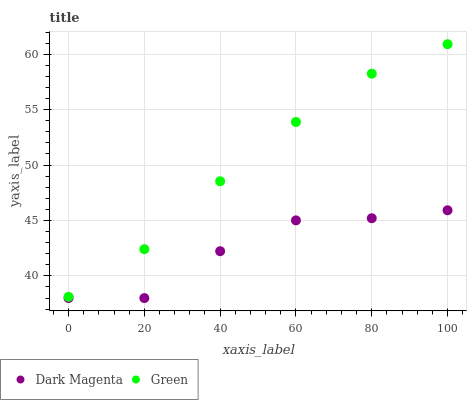Does Dark Magenta have the minimum area under the curve?
Answer yes or no. Yes. Does Green have the maximum area under the curve?
Answer yes or no. Yes. Does Dark Magenta have the maximum area under the curve?
Answer yes or no. No. Is Green the smoothest?
Answer yes or no. Yes. Is Dark Magenta the roughest?
Answer yes or no. Yes. Is Dark Magenta the smoothest?
Answer yes or no. No. Does Dark Magenta have the lowest value?
Answer yes or no. Yes. Does Green have the highest value?
Answer yes or no. Yes. Does Dark Magenta have the highest value?
Answer yes or no. No. Is Dark Magenta less than Green?
Answer yes or no. Yes. Is Green greater than Dark Magenta?
Answer yes or no. Yes. Does Dark Magenta intersect Green?
Answer yes or no. No. 